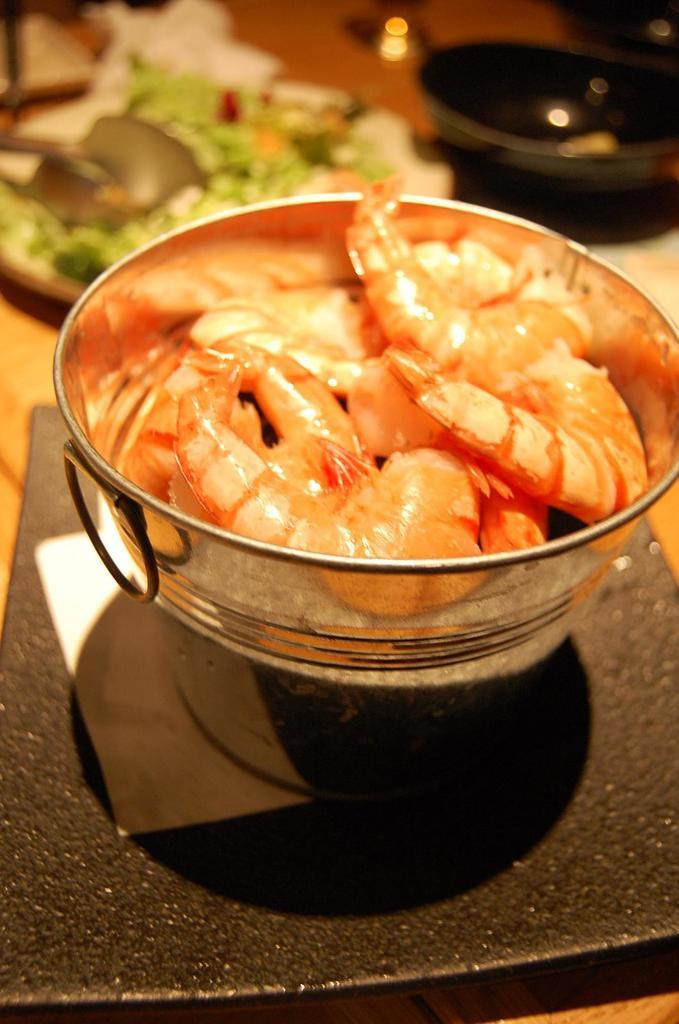What is the main object in the image? There is a bowl in the image. What is the bowl placed on? The bowl is on a black surface. What is inside the bowl? There are prawns in the bowl. Can you describe the background of the image? The background of the image is blurred. Are there any snails visible in the image? No, there are no snails present in the image. What type of heat source is used to cook the prawns in the image? There is no heat source visible in the image, as it only shows a bowl of prawns on a black surface with a blurred background. 